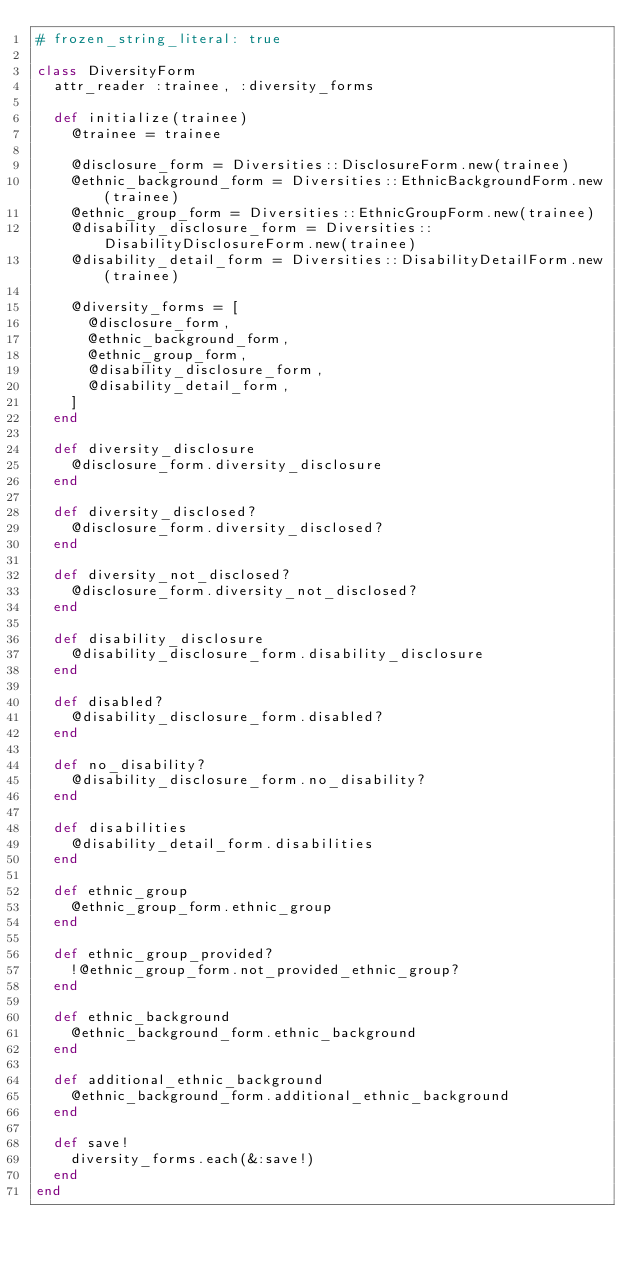<code> <loc_0><loc_0><loc_500><loc_500><_Ruby_># frozen_string_literal: true

class DiversityForm
  attr_reader :trainee, :diversity_forms

  def initialize(trainee)
    @trainee = trainee

    @disclosure_form = Diversities::DisclosureForm.new(trainee)
    @ethnic_background_form = Diversities::EthnicBackgroundForm.new(trainee)
    @ethnic_group_form = Diversities::EthnicGroupForm.new(trainee)
    @disability_disclosure_form = Diversities::DisabilityDisclosureForm.new(trainee)
    @disability_detail_form = Diversities::DisabilityDetailForm.new(trainee)

    @diversity_forms = [
      @disclosure_form,
      @ethnic_background_form,
      @ethnic_group_form,
      @disability_disclosure_form,
      @disability_detail_form,
    ]
  end

  def diversity_disclosure
    @disclosure_form.diversity_disclosure
  end

  def diversity_disclosed?
    @disclosure_form.diversity_disclosed?
  end

  def diversity_not_disclosed?
    @disclosure_form.diversity_not_disclosed?
  end

  def disability_disclosure
    @disability_disclosure_form.disability_disclosure
  end

  def disabled?
    @disability_disclosure_form.disabled?
  end

  def no_disability?
    @disability_disclosure_form.no_disability?
  end

  def disabilities
    @disability_detail_form.disabilities
  end

  def ethnic_group
    @ethnic_group_form.ethnic_group
  end

  def ethnic_group_provided?
    !@ethnic_group_form.not_provided_ethnic_group?
  end

  def ethnic_background
    @ethnic_background_form.ethnic_background
  end

  def additional_ethnic_background
    @ethnic_background_form.additional_ethnic_background
  end

  def save!
    diversity_forms.each(&:save!)
  end
end
</code> 